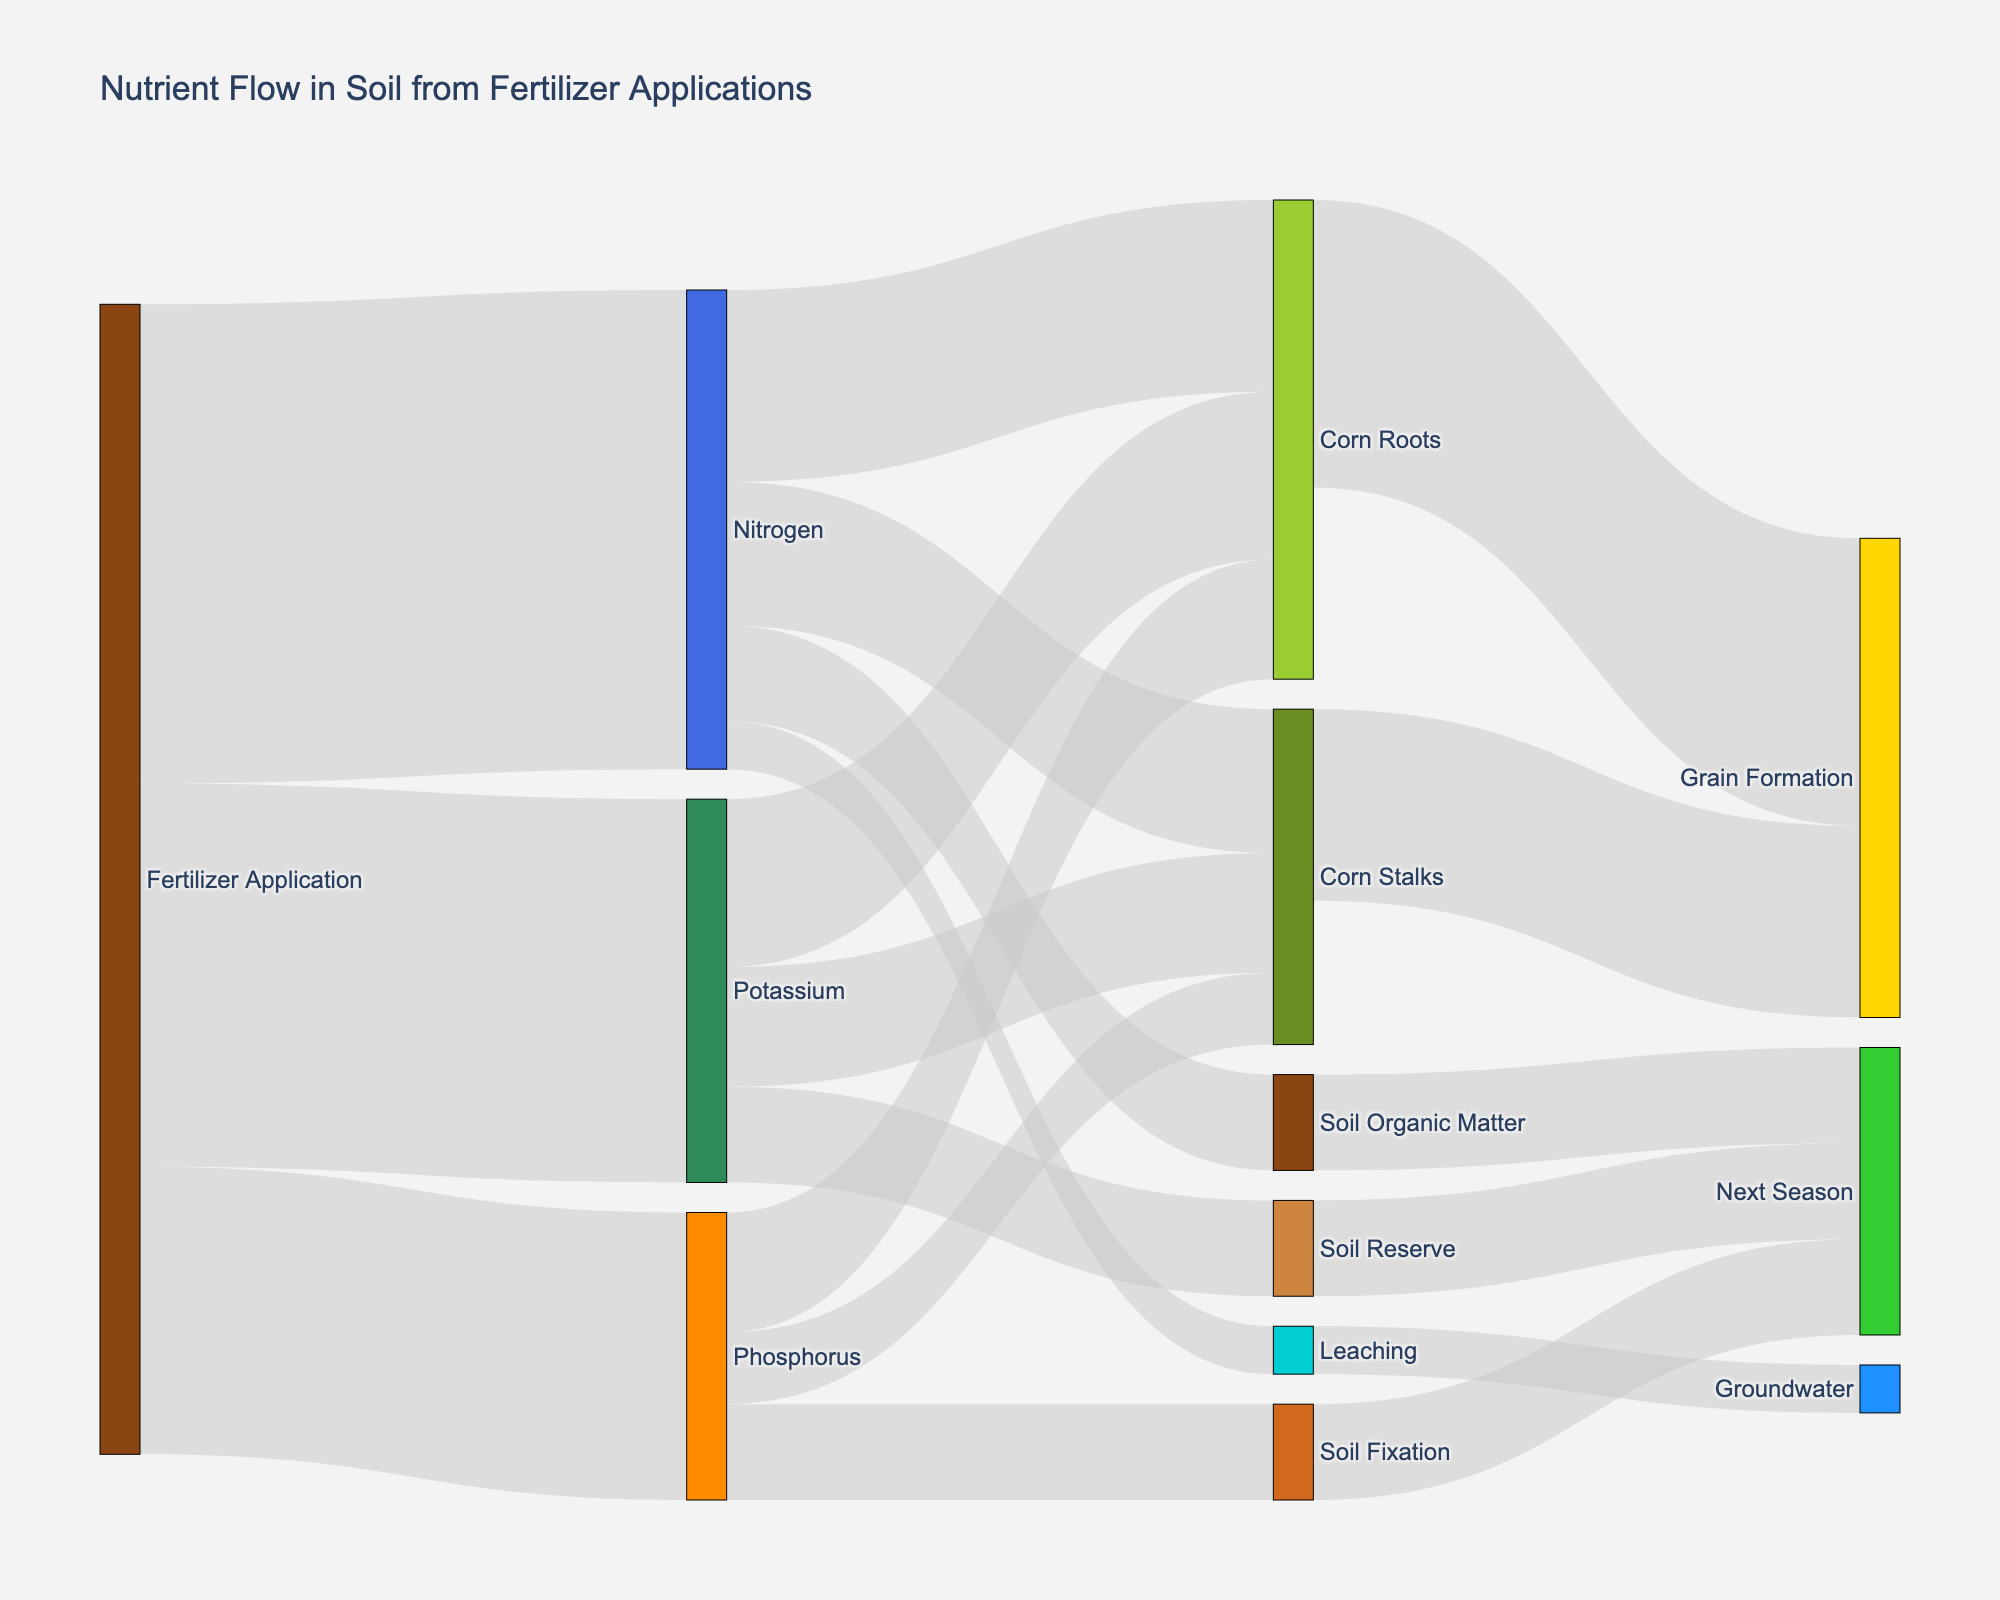How much nitrogen is taken up by corn roots? Refer to the data flow from "Nitrogen" to "Corn Roots" in the Sankey diagram. The value is shown as 40.
Answer: 40 What proportion of phosphorus from fertilizer application goes into soil fixation? Identify the phosphorus flow from "Fertilizer Application" to "Phosphorus", which is 60. Then check the flow from "Phosphorus" to "Soil Fixation", which is 20. Calculate 20/60*100%.
Answer: 33.33% Which nutrient has the least amount lost to leaching? Examine the links labeled "Leaching" under each nutrient. Only "Nitrogen" has a link to "Leaching" with a value of 10. Since no other nutrients have leaching values, nitrogen is the answer.
Answer: Nitrogen Between nitrogen, phosphorus, and potassium, which faciliates greater grain formation through corn roots? Compare the values of flows from "Corn Roots" to "Grain Formation". Nitrogen facilitates 40 and phosphorus and potassium facilitate 60. Therefore, phosphorus and potassium have equal larger facilitation compared to nitrogen.
Answer: Phosphorus and Potassium What is the total amount of nutrient that goes into the next season? Calculate the sum of the flows to "Next Season": 20 (Soil Organic Matter) + 20 (Soil Fixation) + 20 (Soil Reserve). The total is 60.
Answer: 60 How does the amount of potassium in corn stalks compare to that in corn roots? Compare the flows from "Potassium" to "Corn Stalks" (25) and "Corn Roots" (35). Corn roots receive more potassium than corn stalks.
Answer: Corn roots receive more Which nutrient has the highest application value initially? Compare the initial values of "Fertilizer Application" to "Nitrogen" (100), "Phosphorus" (60), and "Potassium" (80). Nitrogen has the highest value.
Answer: Nitrogen Among nitrogen, phosphorus, and potassium, which has the highest remaining amount in the soil by the end of the season? Sum the remaining values in the next season for each nutrient: Nitrogen (20), Phosphorus (20), Potassium (20). All have equal next season values.
Answer: Equal How much of the fertilizer application is converted to soil organic matter? Find the flow from "Nitrogen" to "Soil Organic Matter", which is 20.
Answer: 20 